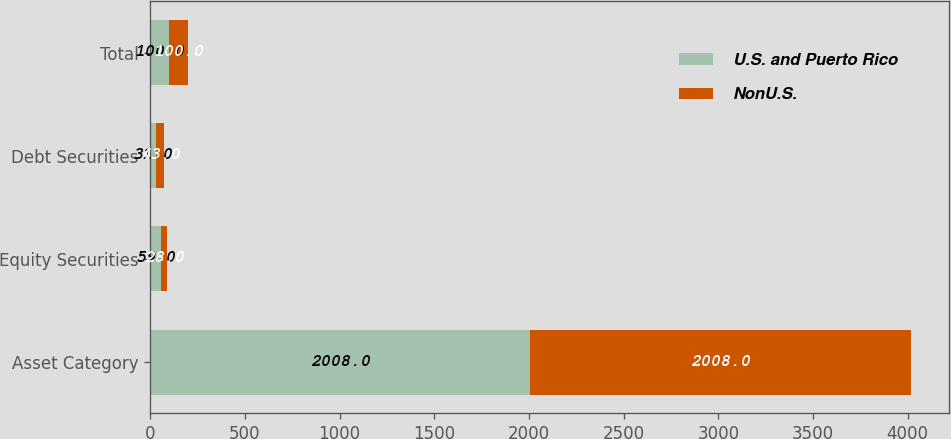Convert chart to OTSL. <chart><loc_0><loc_0><loc_500><loc_500><stacked_bar_chart><ecel><fcel>Asset Category<fcel>Equity Securities<fcel>Debt Securities<fcel>Total<nl><fcel>U.S. and Puerto Rico<fcel>2008<fcel>59<fcel>31<fcel>100<nl><fcel>NonU.S.<fcel>2008<fcel>28<fcel>43<fcel>100<nl></chart> 